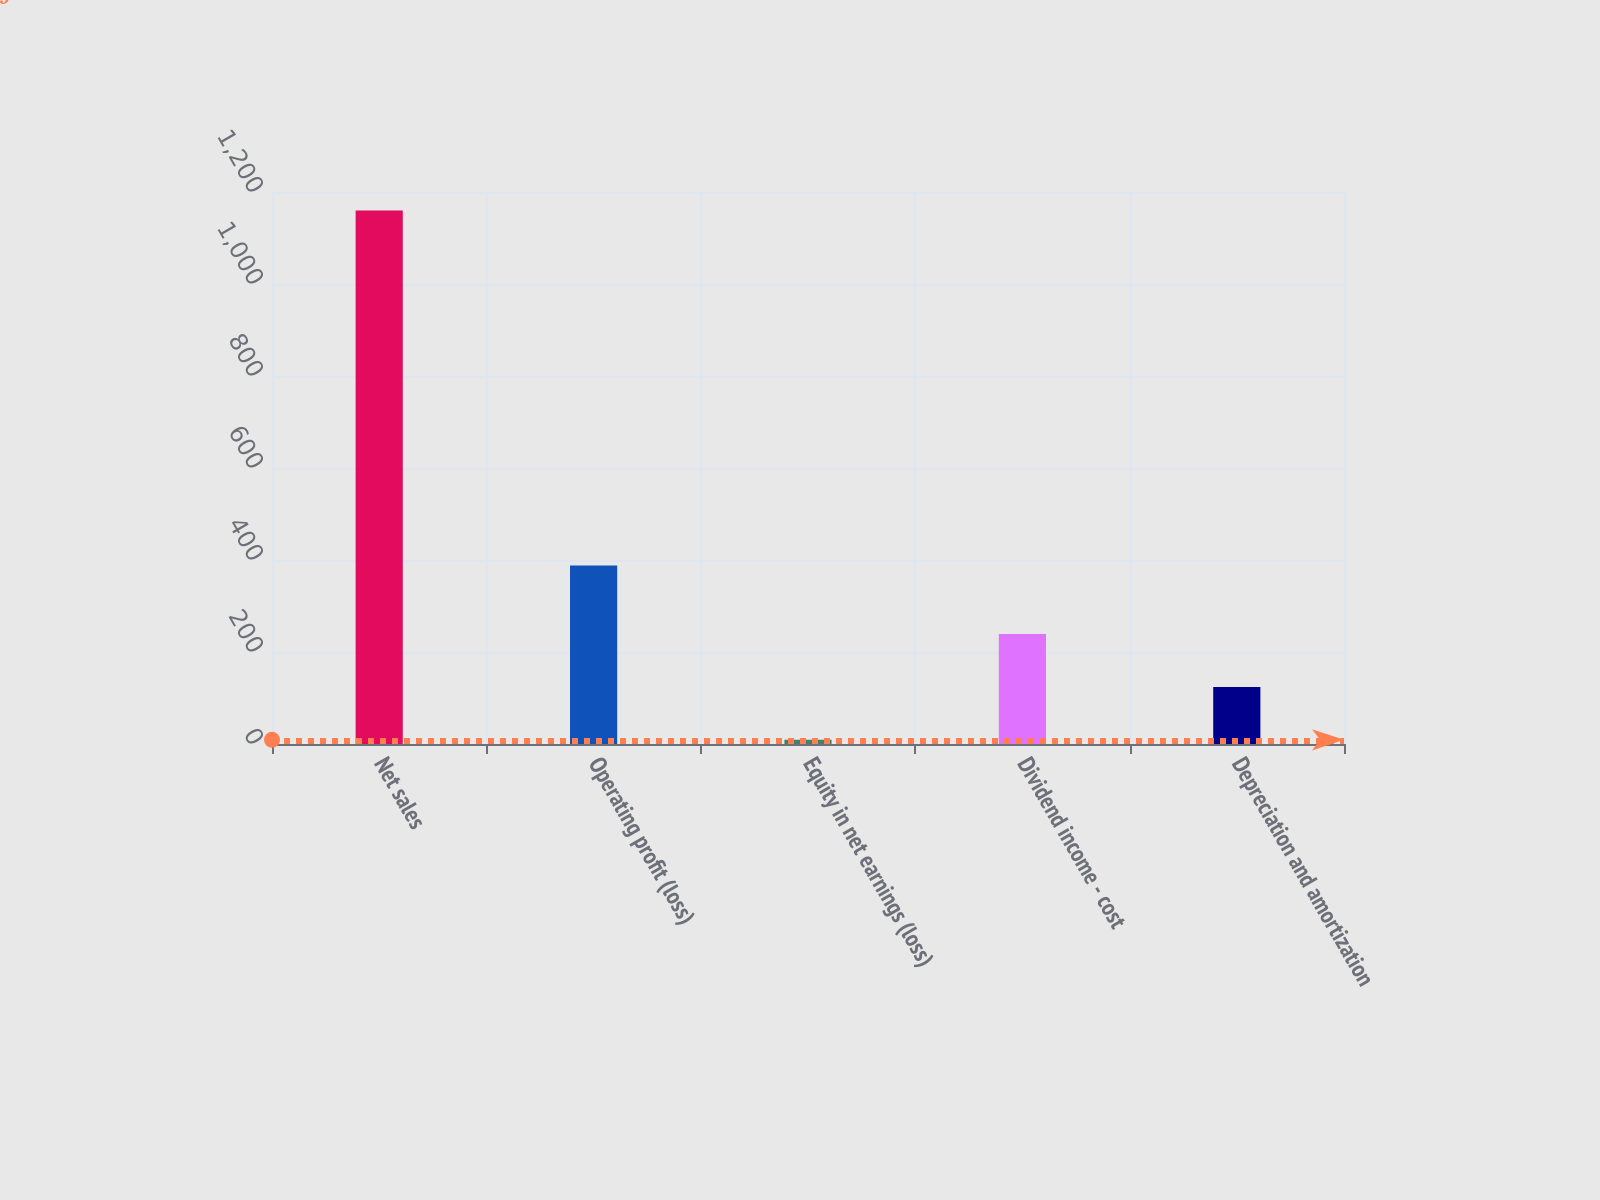<chart> <loc_0><loc_0><loc_500><loc_500><bar_chart><fcel>Net sales<fcel>Operating profit (loss)<fcel>Equity in net earnings (loss)<fcel>Dividend income - cost<fcel>Depreciation and amortization<nl><fcel>1160<fcel>388<fcel>9<fcel>239.2<fcel>124.1<nl></chart> 